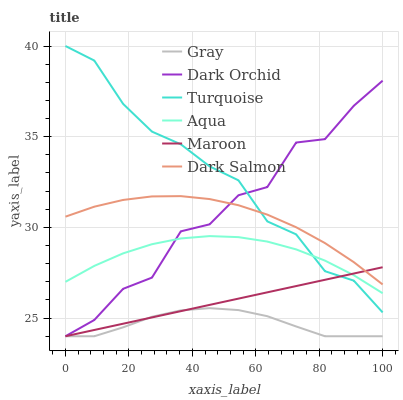Does Gray have the minimum area under the curve?
Answer yes or no. Yes. Does Turquoise have the maximum area under the curve?
Answer yes or no. Yes. Does Aqua have the minimum area under the curve?
Answer yes or no. No. Does Aqua have the maximum area under the curve?
Answer yes or no. No. Is Maroon the smoothest?
Answer yes or no. Yes. Is Dark Orchid the roughest?
Answer yes or no. Yes. Is Turquoise the smoothest?
Answer yes or no. No. Is Turquoise the roughest?
Answer yes or no. No. Does Turquoise have the lowest value?
Answer yes or no. No. Does Turquoise have the highest value?
Answer yes or no. Yes. Does Aqua have the highest value?
Answer yes or no. No. Is Gray less than Turquoise?
Answer yes or no. Yes. Is Aqua greater than Gray?
Answer yes or no. Yes. Does Maroon intersect Turquoise?
Answer yes or no. Yes. Is Maroon less than Turquoise?
Answer yes or no. No. Is Maroon greater than Turquoise?
Answer yes or no. No. Does Gray intersect Turquoise?
Answer yes or no. No. 